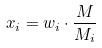<formula> <loc_0><loc_0><loc_500><loc_500>x _ { i } = w _ { i } \cdot \frac { M } { M _ { i } }</formula> 